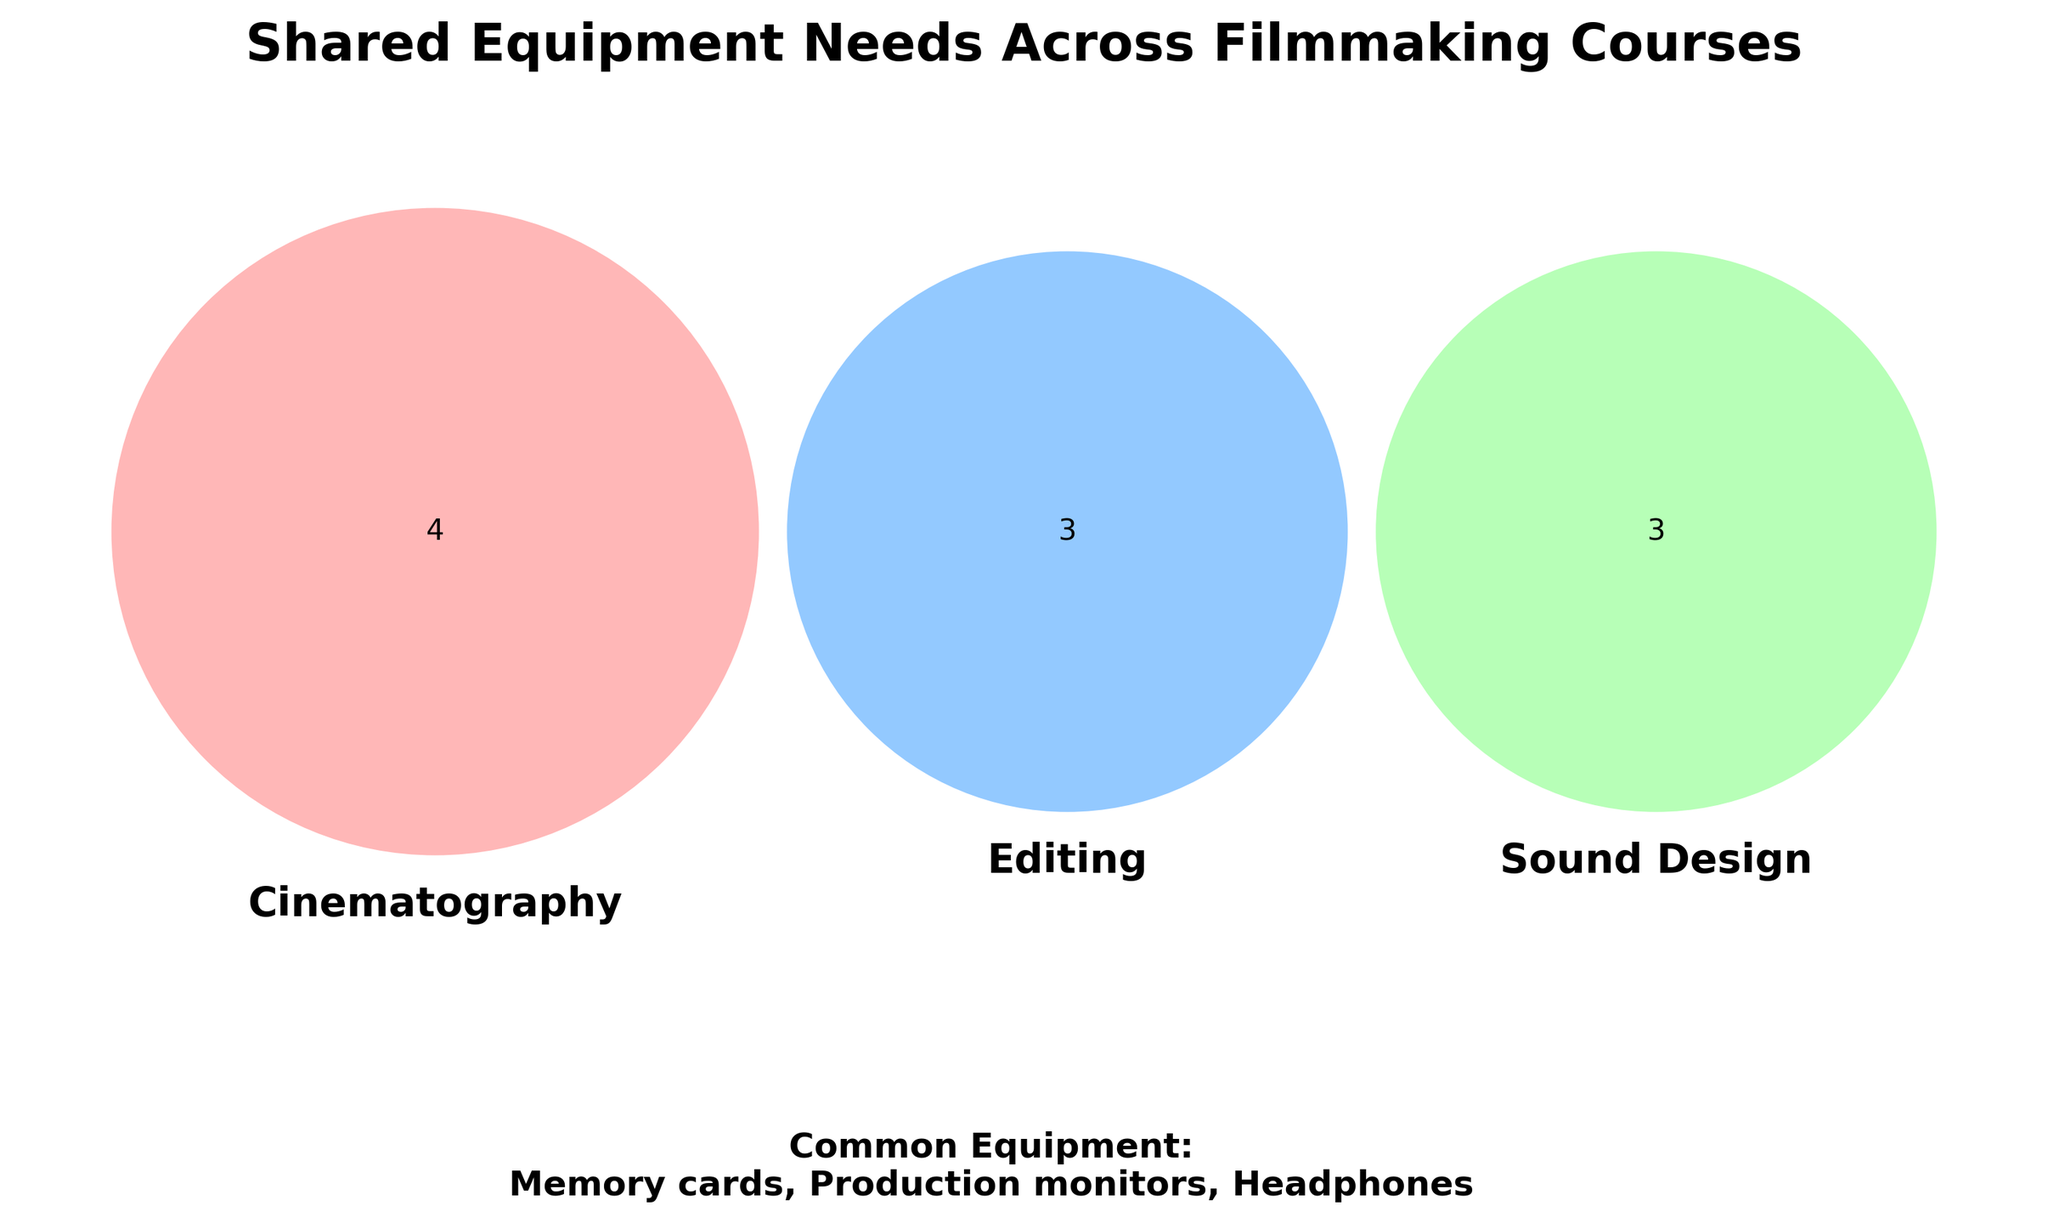What's the title of the figure? The title is usually placed at the top of the figure, often in larger, bold text. In this figure, it states the main focus of the visualization.
Answer: Shared Equipment Needs Across Filmmaking Courses Which equipment is common to all courses? The equipment shared across all courses should be mentioned outside the Venn diagram, typically in a different section for clarity.
Answer: Production monitors, Headphones, Memory cards How many equipment items are unique to Cinematography? To find this, look at the section of the Venn diagram that only intersects with Cinematography.
Answer: Four Which equipment items are common between Sound Design and Editing? Check the overlapping region that includes both Sound Design and Editing.
Answer: None Between Cinematography and Editing, which course has more unique equipment items? Compare the number of unique items in the Cinematography section vs. the unique items in the Editing section.
Answer: Cinematography If a new filmmaking course is introduced, which common equipment should it definitely include? Refer to the equipment labeled as common for all courses in the text section of the figure.
Answer: Production monitors, Headphones, Memory cards Which courses require High-performance computers and External hard drives? Identify the sections of the Venn diagram labeled for specific equipment items needed.
Answer: Editing Combining the needs of Cinematography and Sound Design, how many total unique equipment items are there? Add the unique equipment items from Cinematography and Sound Design.
Answer: Eight Which course requires the least amount of unique equipment? Compare the numbers of unique items listed in each course's exclusive section.
Answer: Sound Design Does Editing share any common equipment with Cinematography? Look at the overlapping area between Editing and Cinematography in the Venn diagram.
Answer: No 